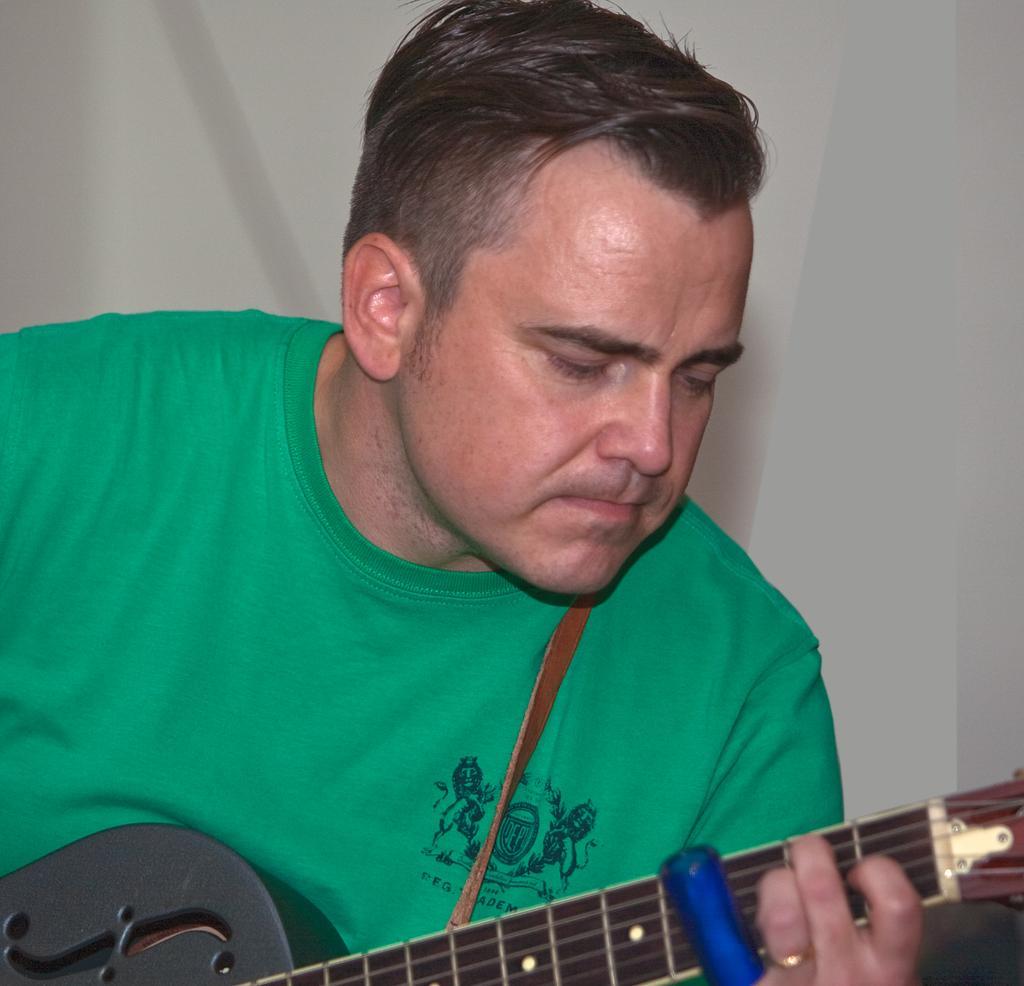Can you describe this image briefly? In this picture we have a person in green shirt holding a guitar and playing it. 